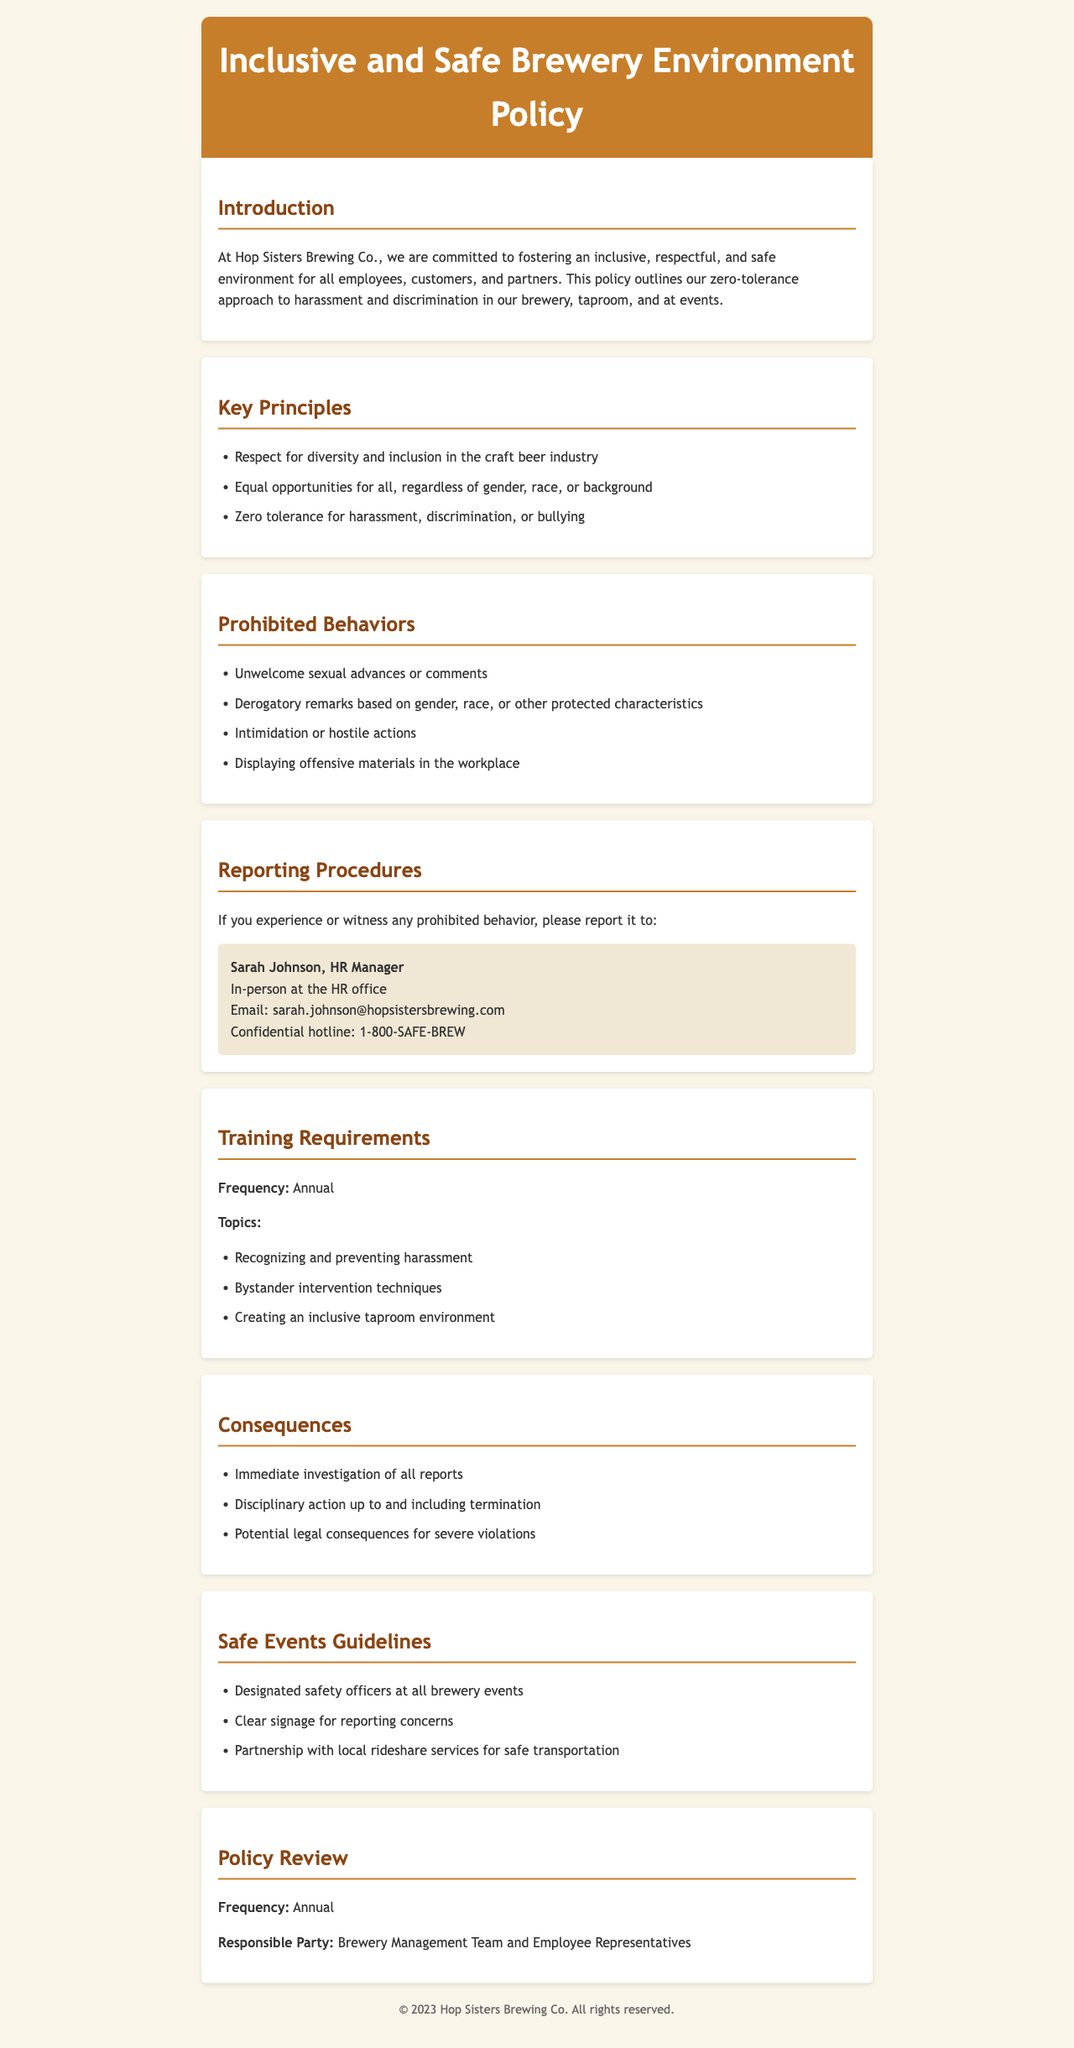What is the primary commitment of Hop Sisters Brewing Co.? The primary commitment is to fostering an inclusive, respectful, and safe environment for all employees, customers, and partners.
Answer: inclusive, respectful, and safe environment Who is the HR Manager to contact for reporting prohibited behavior? The name of the HR Manager who handles reporting is mentioned in the document.
Answer: Sarah Johnson What hotline can employees use for confidential reporting? The document provides a hotline for confidential reporting of prohibited behavior.
Answer: 1-800-SAFE-BREW What type of training is required annually? The document lists required training topics that are conducted annually.
Answer: Recognizing and preventing harassment What is the consequence for severe violations of the policy? The document outlines potential legal consequences for severe violations, which are categorized in a specific manner.
Answer: Potential legal consequences How often is the policy reviewed? The frequency of policy review is explicitly stated in the document.
Answer: Annual What is the first key principle outlined in the policy? The document lists several key principles and identifies the first one specifically.
Answer: Respect for diversity and inclusion in the craft beer industry What safety measure is mentioned for brewery events? The document highlights a specific safety measure related to designated personnel at events.
Answer: Designated safety officers What action could lead to termination as stated in the consequences section? The document states that there is a specific action that can lead to termination.
Answer: Disciplinary action up to and including termination 